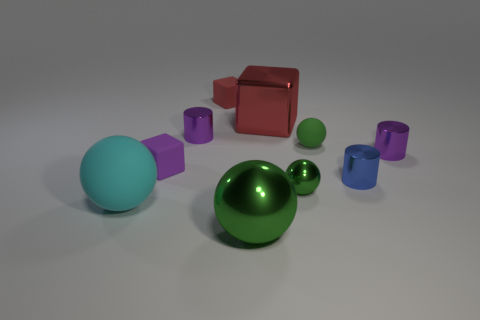How many other things are the same size as the cyan object?
Make the answer very short. 2. Do the big rubber thing and the small cylinder that is on the left side of the big red thing have the same color?
Your answer should be compact. No. How many blocks are either red objects or blue things?
Offer a very short reply. 2. Are there any other things that have the same color as the big matte ball?
Your response must be concise. No. There is a tiny cube that is on the right side of the purple cube that is right of the large matte ball; what is its material?
Your answer should be compact. Rubber. Is the material of the blue cylinder the same as the green ball that is in front of the large cyan ball?
Offer a terse response. Yes. What number of objects are small blue shiny cylinders on the right side of the metal cube or small blue metal things?
Your answer should be compact. 1. Is there a large object that has the same color as the small metal ball?
Your answer should be very brief. Yes. There is a small blue shiny thing; is it the same shape as the purple shiny object to the right of the small red matte cube?
Your response must be concise. Yes. How many rubber objects are left of the tiny metal ball and to the right of the big rubber object?
Your answer should be very brief. 2. 